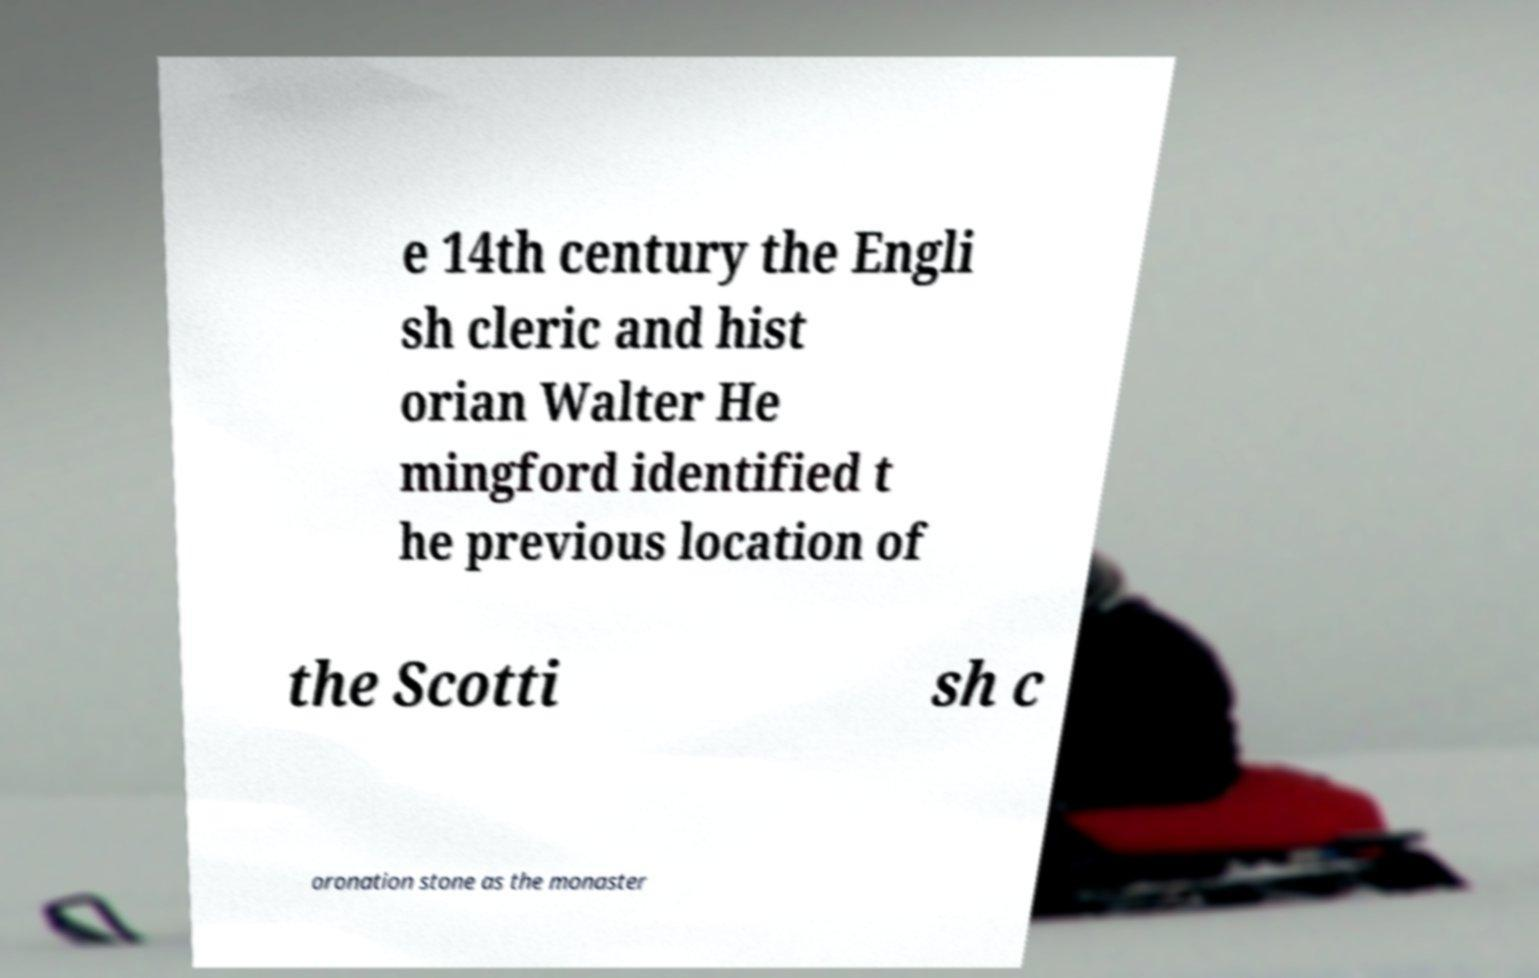Can you accurately transcribe the text from the provided image for me? e 14th century the Engli sh cleric and hist orian Walter He mingford identified t he previous location of the Scotti sh c oronation stone as the monaster 